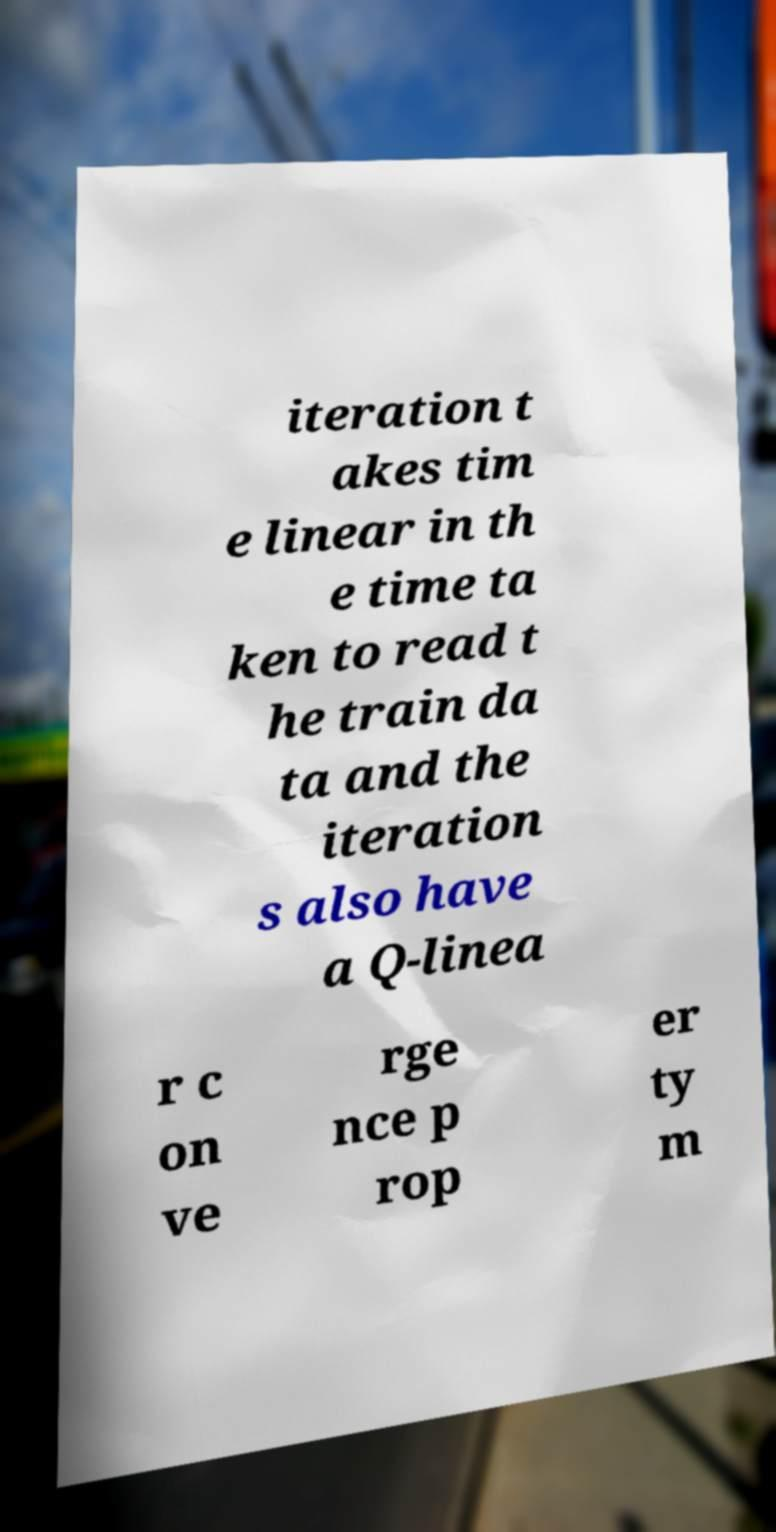Could you assist in decoding the text presented in this image and type it out clearly? iteration t akes tim e linear in th e time ta ken to read t he train da ta and the iteration s also have a Q-linea r c on ve rge nce p rop er ty m 